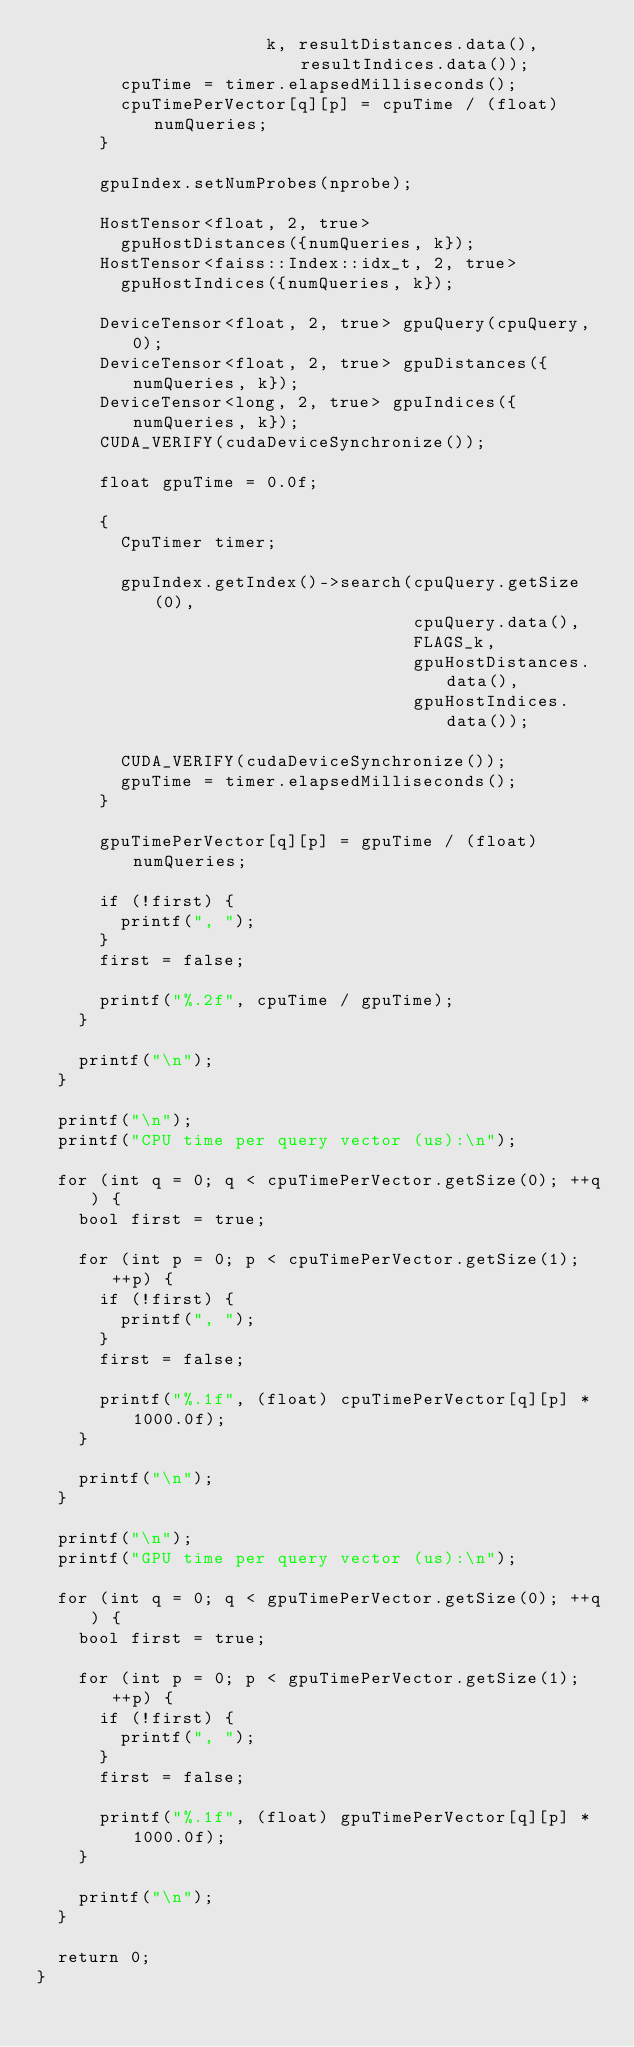Convert code to text. <code><loc_0><loc_0><loc_500><loc_500><_Cuda_>                      k, resultDistances.data(), resultIndices.data());
        cpuTime = timer.elapsedMilliseconds();
        cpuTimePerVector[q][p] = cpuTime / (float) numQueries;
      }

      gpuIndex.setNumProbes(nprobe);

      HostTensor<float, 2, true>
        gpuHostDistances({numQueries, k});
      HostTensor<faiss::Index::idx_t, 2, true>
        gpuHostIndices({numQueries, k});

      DeviceTensor<float, 2, true> gpuQuery(cpuQuery, 0);
      DeviceTensor<float, 2, true> gpuDistances({numQueries, k});
      DeviceTensor<long, 2, true> gpuIndices({numQueries, k});
      CUDA_VERIFY(cudaDeviceSynchronize());

      float gpuTime = 0.0f;

      {
        CpuTimer timer;

        gpuIndex.getIndex()->search(cpuQuery.getSize(0),
                                    cpuQuery.data(),
                                    FLAGS_k,
                                    gpuHostDistances.data(),
                                    gpuHostIndices.data());

        CUDA_VERIFY(cudaDeviceSynchronize());
        gpuTime = timer.elapsedMilliseconds();
      }

      gpuTimePerVector[q][p] = gpuTime / (float) numQueries;

      if (!first) {
        printf(", ");
      }
      first = false;

      printf("%.2f", cpuTime / gpuTime);
    }

    printf("\n");
  }

  printf("\n");
  printf("CPU time per query vector (us):\n");

  for (int q = 0; q < cpuTimePerVector.getSize(0); ++q) {
    bool first = true;

    for (int p = 0; p < cpuTimePerVector.getSize(1); ++p) {
      if (!first) {
        printf(", ");
      }
      first = false;

      printf("%.1f", (float) cpuTimePerVector[q][p] * 1000.0f);
    }

    printf("\n");
  }

  printf("\n");
  printf("GPU time per query vector (us):\n");

  for (int q = 0; q < gpuTimePerVector.getSize(0); ++q) {
    bool first = true;

    for (int p = 0; p < gpuTimePerVector.getSize(1); ++p) {
      if (!first) {
        printf(", ");
      }
      first = false;

      printf("%.1f", (float) gpuTimePerVector[q][p] * 1000.0f);
    }

    printf("\n");
  }

  return 0;
}
</code> 